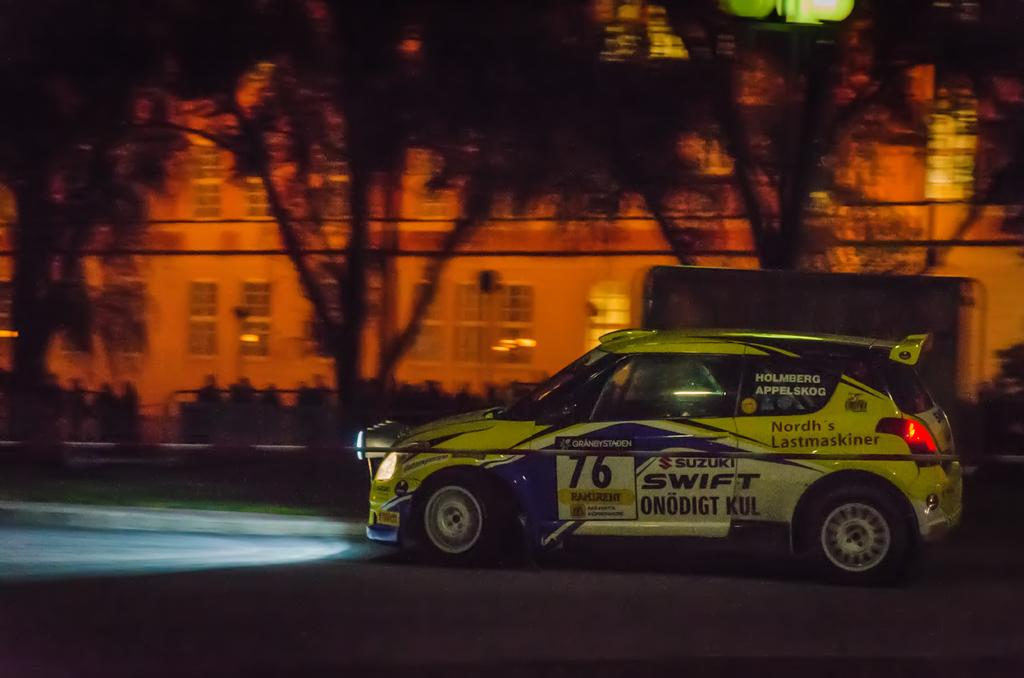What is located on the right side of the image? There is a vehicle on the right side of the image. Where is the vehicle situated? The vehicle is on a road. What can be seen in the background of the image? There are trees, plants, and a building with windows in the background of the image. Can you see your uncle driving the vehicle in the image? There is no reference to an uncle or anyone driving the vehicle in the image. 